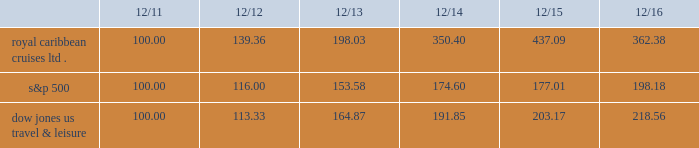Performance graph the following graph compares the total return , assuming reinvestment of dividends , on an investment in the company , based on performance of the company's common stock , with the total return of the standard & poor's 500 composite stock index and the dow jones united states travel and leisure index for a five year period by measuring the changes in common stock prices from december 31 , 2011 to december 31 , 2016. .
The stock performance graph assumes for comparison that the value of the company's common stock and of each index was $ 100 on december 31 , 2011 and that all dividends were reinvested .
Past performance is not necessarily an indicator of future results. .
What is the mathematical range for royal caribean , s&p 500 and dow jones in december , 2014? 
Computations: (350.40 - 177.01)
Answer: 173.39. 